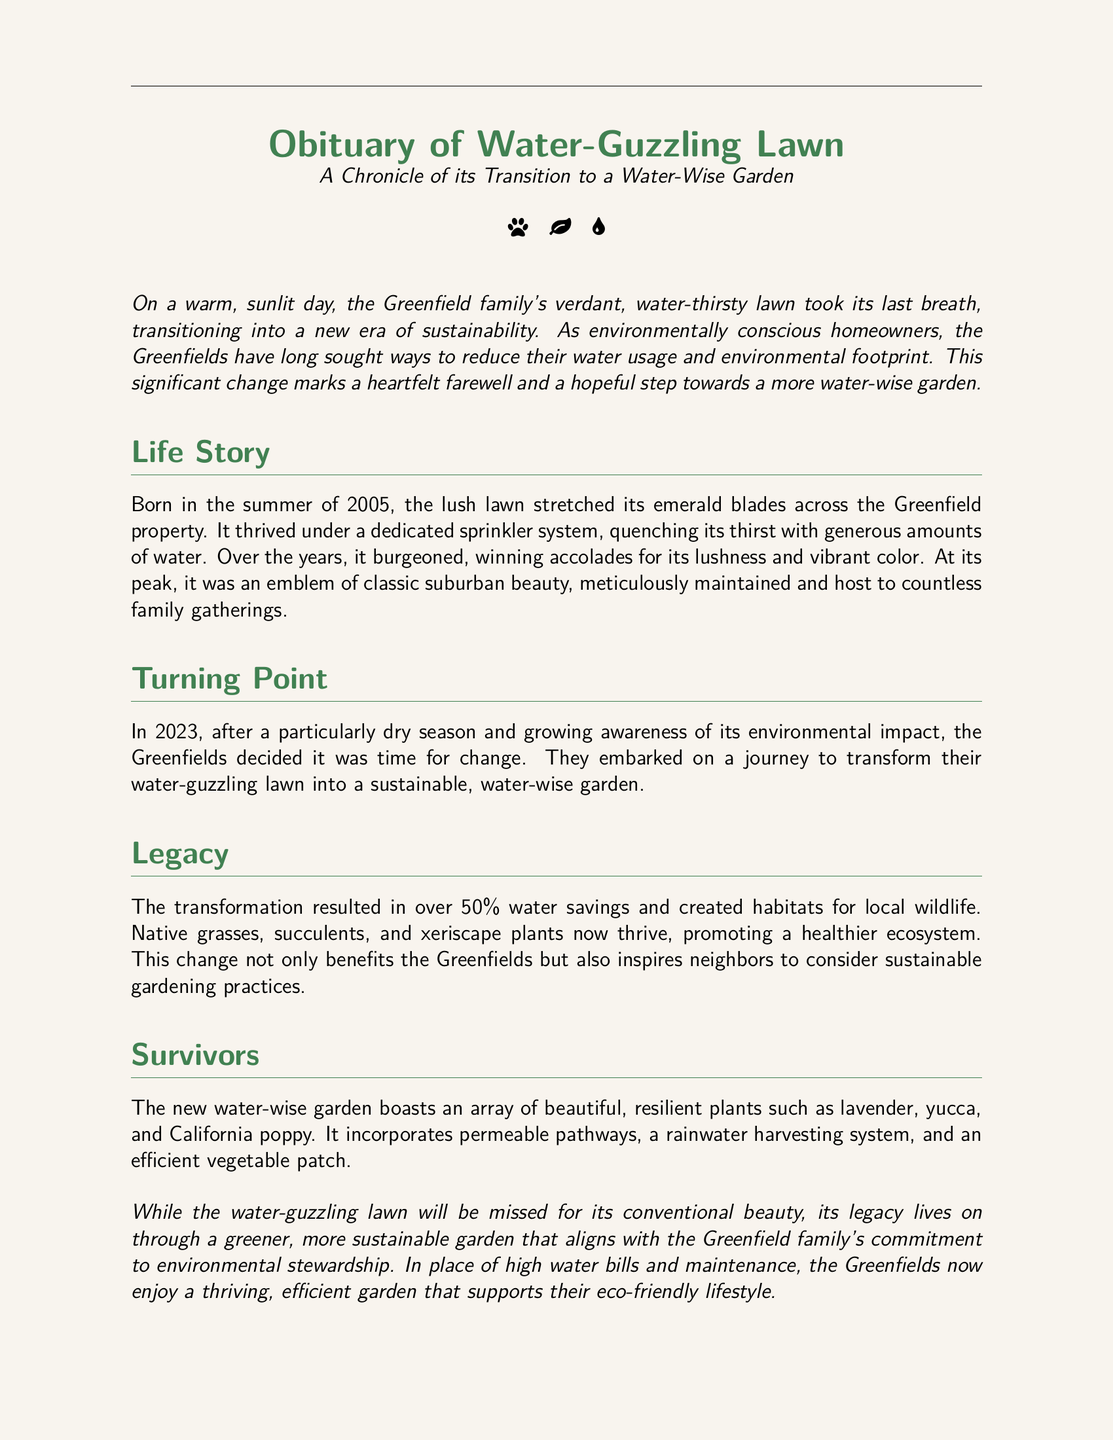What year was the lawn born? The document states that the lawn was born in the summer of 2005.
Answer: 2005 How much water savings resulted from the transformation? The document mentions over 50% water savings following the transformation.
Answer: 50% What types of plants now thrive in the new garden? It lists lavender, yucca, and California poppy as resilient plants in the new garden.
Answer: lavender, yucca, California poppy In what year did the Greenfields decide to make the change? The document indicates that the Greenfields decided to change in 2023.
Answer: 2023 What was a notable feature of the lawn during its peak? The document describes it as an emblem of classic suburban beauty.
Answer: emblem of classic suburban beauty What did the transformation contribute to local wildlife? The document highlights that the transformation created habitats for local wildlife.
Answer: habitats What installation helps collect rainwater in the new garden? The document mentions a rainwater harvesting system as part of the new garden.
Answer: rainwater harvesting system What is one benefit mentioned about the new garden? The document states it supports their eco-friendly lifestyle.
Answer: eco-friendly lifestyle What emotion is expressed regarding the water-guzzling lawn's change? The document conveys a heartfelt farewell to the lawn.
Answer: heartfelt farewell 